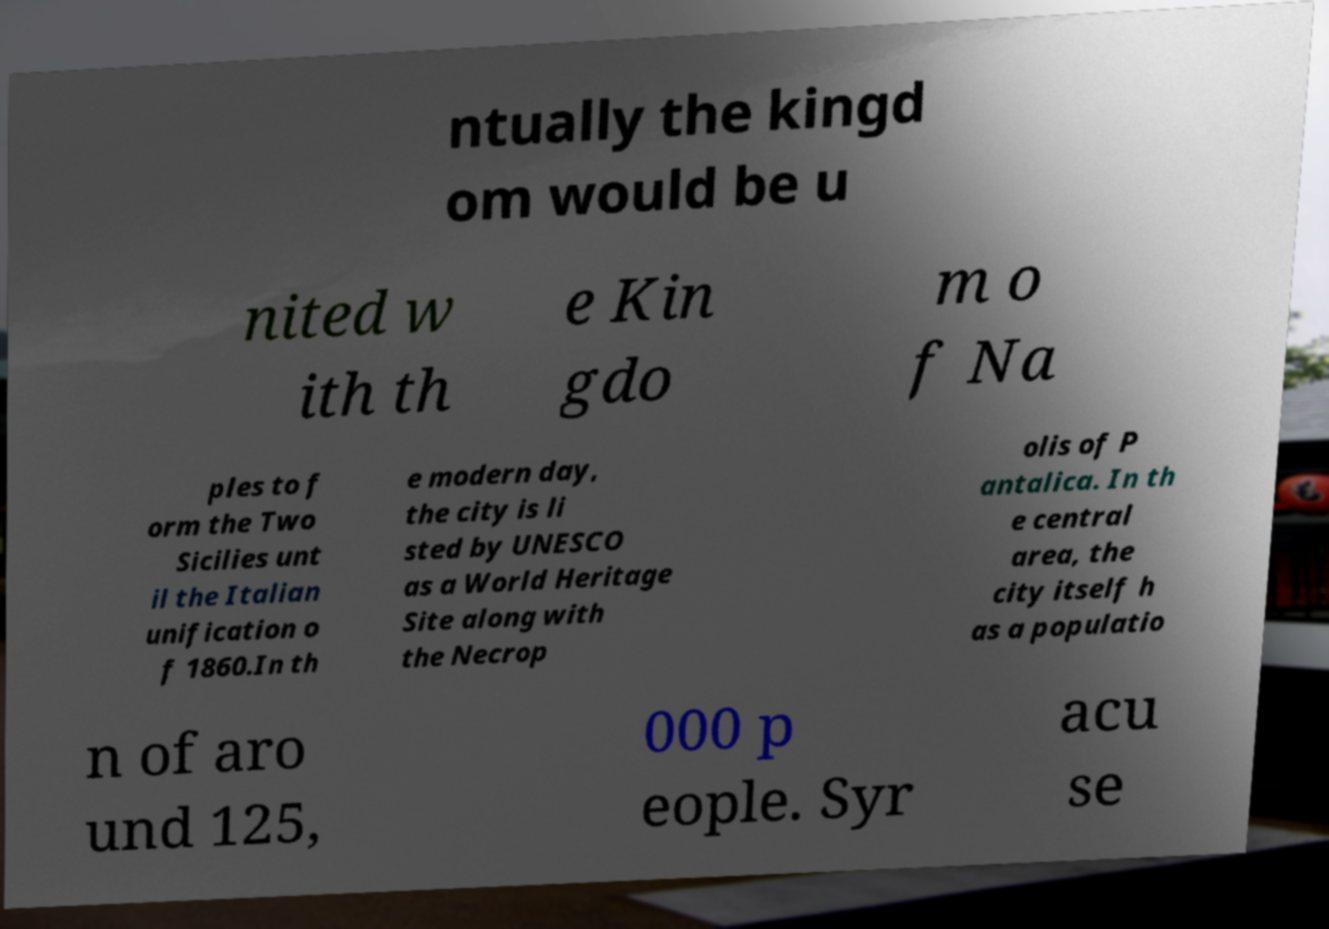Can you read and provide the text displayed in the image?This photo seems to have some interesting text. Can you extract and type it out for me? ntually the kingd om would be u nited w ith th e Kin gdo m o f Na ples to f orm the Two Sicilies unt il the Italian unification o f 1860.In th e modern day, the city is li sted by UNESCO as a World Heritage Site along with the Necrop olis of P antalica. In th e central area, the city itself h as a populatio n of aro und 125, 000 p eople. Syr acu se 